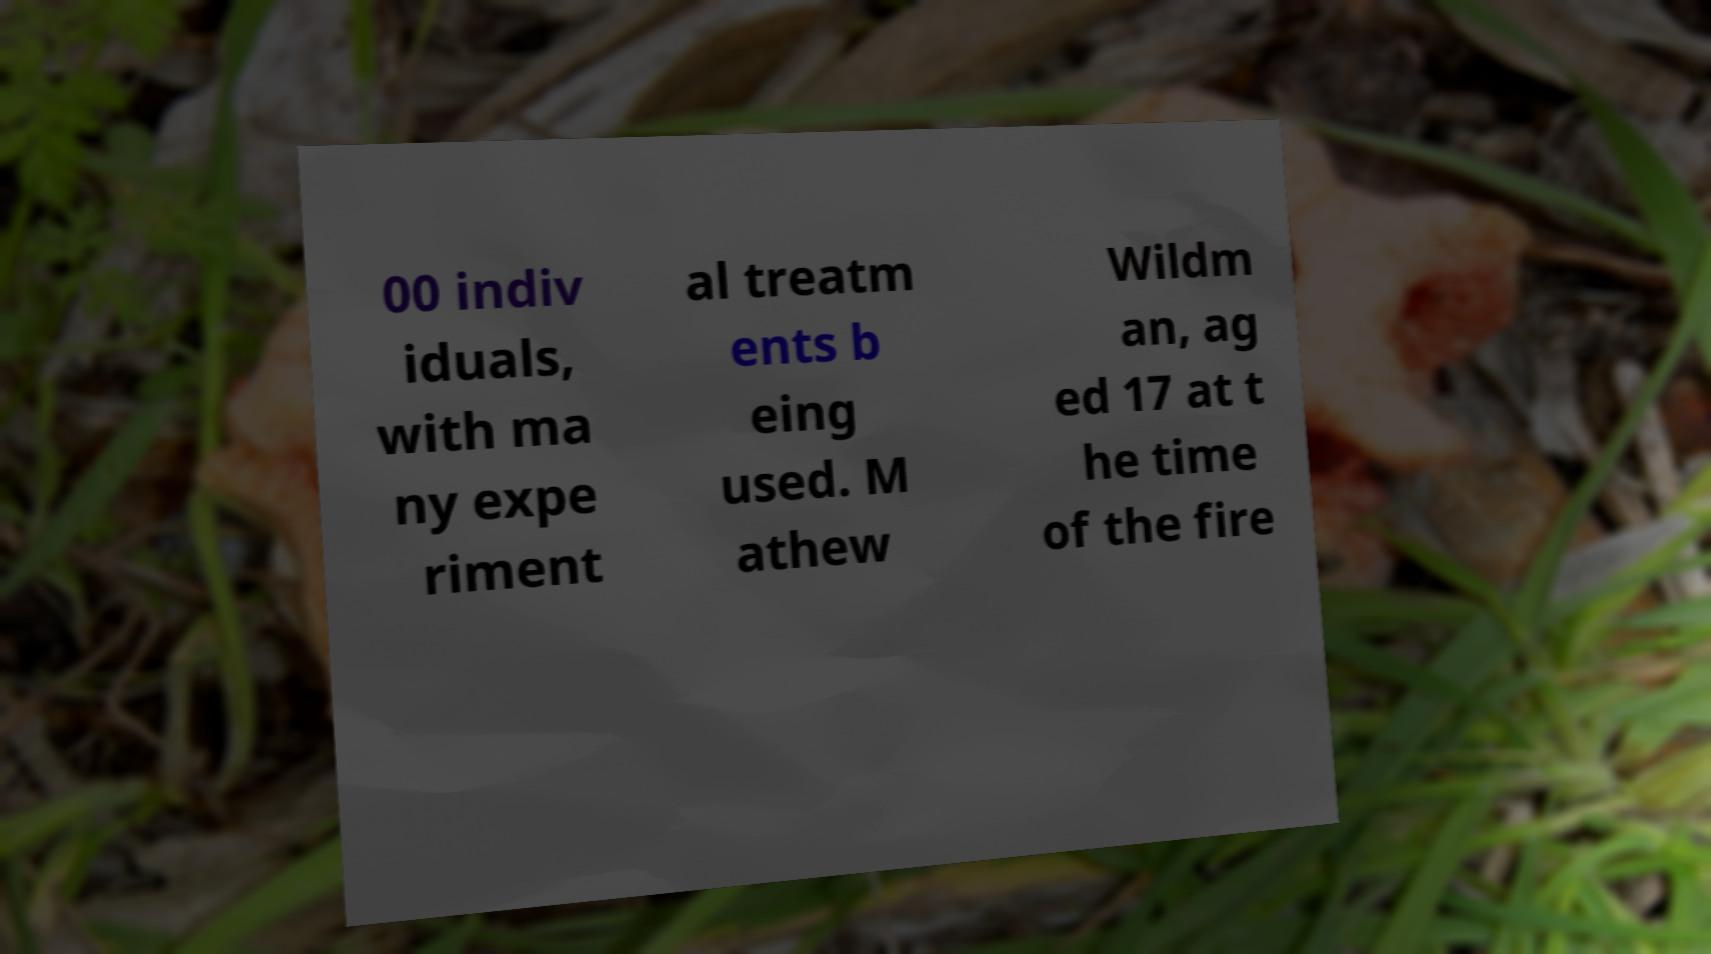For documentation purposes, I need the text within this image transcribed. Could you provide that? 00 indiv iduals, with ma ny expe riment al treatm ents b eing used. M athew Wildm an, ag ed 17 at t he time of the fire 